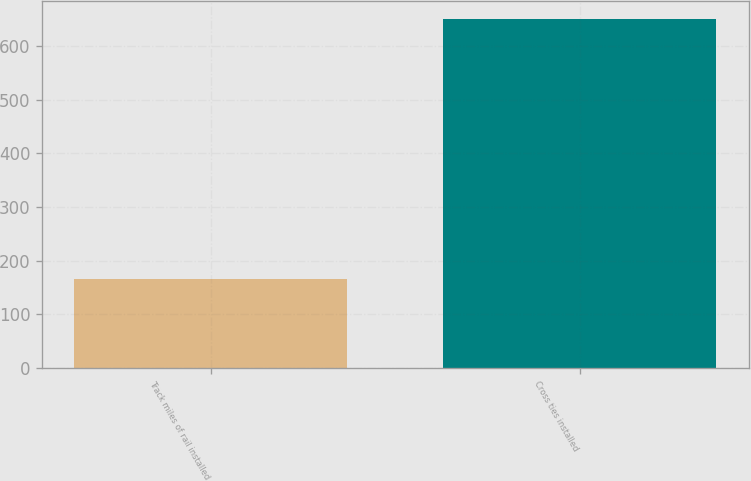Convert chart to OTSL. <chart><loc_0><loc_0><loc_500><loc_500><bar_chart><fcel>Track miles of rail installed<fcel>Cross ties installed<nl><fcel>166<fcel>651<nl></chart> 